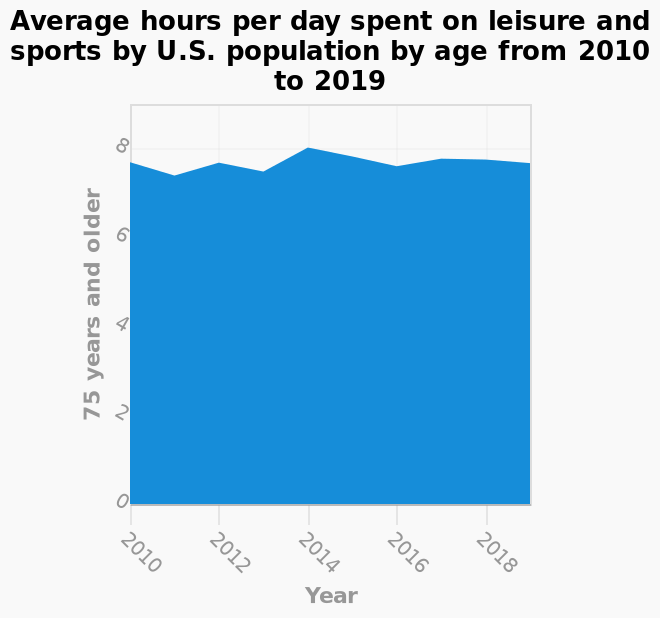<image>
please describe the details of the chart Average hours per day spent on leisure and sports by U.S. population by age from 2010 to 2019 is a area graph. The y-axis measures 75 years and older on linear scale of range 0 to 8 while the x-axis plots Year along linear scale of range 2010 to 2018. What is the average number of hours per day mentioned in the figure?  The average number of hours per day mentioned in the figure is approximately 7.5 hours. How consistent is the average number of hours per day over the period? The average number of hours per day is fairly consistent over the period, as mentioned in the description. What does the x-axis represent on the graph?  The x-axis plots the years from 2010 to 2018 on a linear scale. What is the type of graph used to represent the data?  The data is represented in an area graph. 